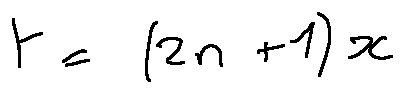<formula> <loc_0><loc_0><loc_500><loc_500>t = ( 2 n + 1 ) x</formula> 